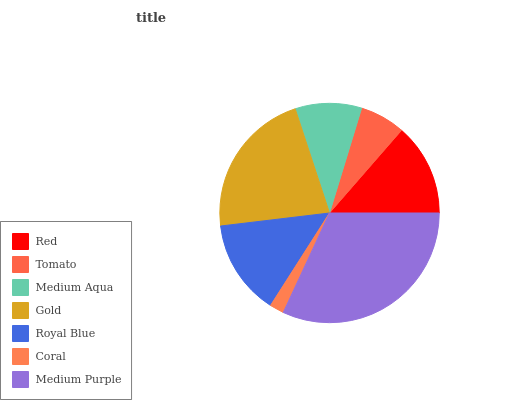Is Coral the minimum?
Answer yes or no. Yes. Is Medium Purple the maximum?
Answer yes or no. Yes. Is Tomato the minimum?
Answer yes or no. No. Is Tomato the maximum?
Answer yes or no. No. Is Red greater than Tomato?
Answer yes or no. Yes. Is Tomato less than Red?
Answer yes or no. Yes. Is Tomato greater than Red?
Answer yes or no. No. Is Red less than Tomato?
Answer yes or no. No. Is Red the high median?
Answer yes or no. Yes. Is Red the low median?
Answer yes or no. Yes. Is Medium Aqua the high median?
Answer yes or no. No. Is Medium Purple the low median?
Answer yes or no. No. 